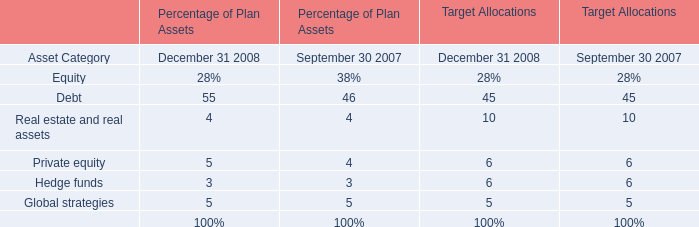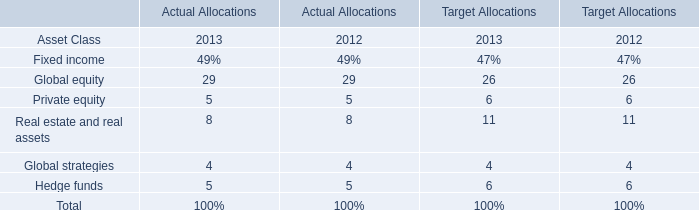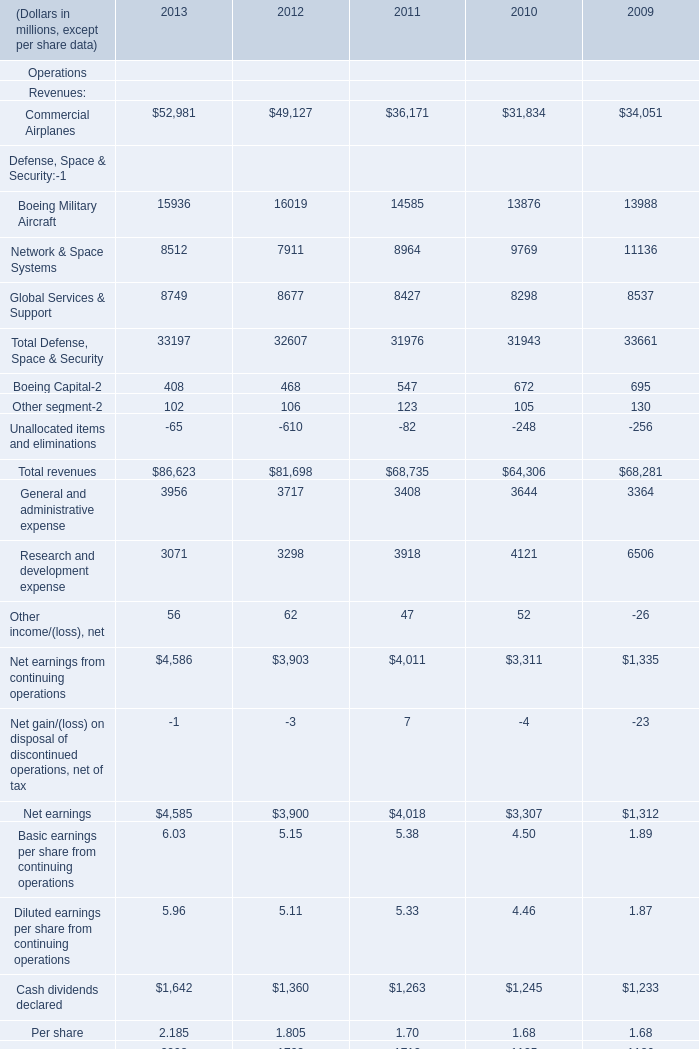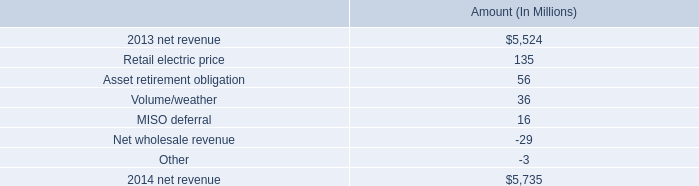What's the total amount of the Contractual Backlog: Commercial Airplanes in the years where Revenues:Commercial Airplanes for Operations is greater than 0? (in million) 
Computations: ((((372980 + 317287) + 293303) + 255591) + 250476)
Answer: 1489637.0. 